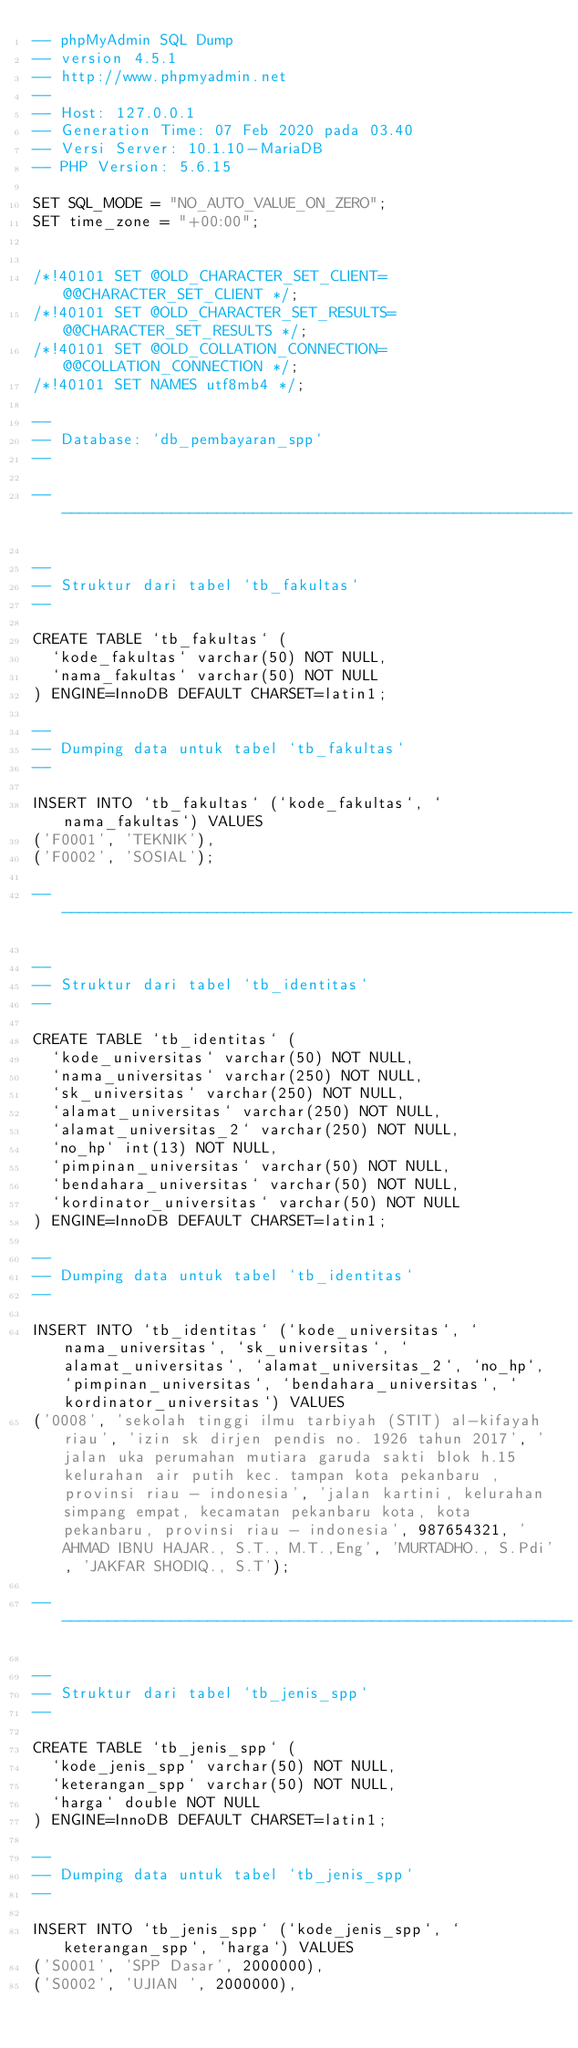<code> <loc_0><loc_0><loc_500><loc_500><_SQL_>-- phpMyAdmin SQL Dump
-- version 4.5.1
-- http://www.phpmyadmin.net
--
-- Host: 127.0.0.1
-- Generation Time: 07 Feb 2020 pada 03.40
-- Versi Server: 10.1.10-MariaDB
-- PHP Version: 5.6.15

SET SQL_MODE = "NO_AUTO_VALUE_ON_ZERO";
SET time_zone = "+00:00";


/*!40101 SET @OLD_CHARACTER_SET_CLIENT=@@CHARACTER_SET_CLIENT */;
/*!40101 SET @OLD_CHARACTER_SET_RESULTS=@@CHARACTER_SET_RESULTS */;
/*!40101 SET @OLD_COLLATION_CONNECTION=@@COLLATION_CONNECTION */;
/*!40101 SET NAMES utf8mb4 */;

--
-- Database: `db_pembayaran_spp`
--

-- --------------------------------------------------------

--
-- Struktur dari tabel `tb_fakultas`
--

CREATE TABLE `tb_fakultas` (
  `kode_fakultas` varchar(50) NOT NULL,
  `nama_fakultas` varchar(50) NOT NULL
) ENGINE=InnoDB DEFAULT CHARSET=latin1;

--
-- Dumping data untuk tabel `tb_fakultas`
--

INSERT INTO `tb_fakultas` (`kode_fakultas`, `nama_fakultas`) VALUES
('F0001', 'TEKNIK'),
('F0002', 'SOSIAL');

-- --------------------------------------------------------

--
-- Struktur dari tabel `tb_identitas`
--

CREATE TABLE `tb_identitas` (
  `kode_universitas` varchar(50) NOT NULL,
  `nama_universitas` varchar(250) NOT NULL,
  `sk_universitas` varchar(250) NOT NULL,
  `alamat_universitas` varchar(250) NOT NULL,
  `alamat_universitas_2` varchar(250) NOT NULL,
  `no_hp` int(13) NOT NULL,
  `pimpinan_universitas` varchar(50) NOT NULL,
  `bendahara_universitas` varchar(50) NOT NULL,
  `kordinator_universitas` varchar(50) NOT NULL
) ENGINE=InnoDB DEFAULT CHARSET=latin1;

--
-- Dumping data untuk tabel `tb_identitas`
--

INSERT INTO `tb_identitas` (`kode_universitas`, `nama_universitas`, `sk_universitas`, `alamat_universitas`, `alamat_universitas_2`, `no_hp`, `pimpinan_universitas`, `bendahara_universitas`, `kordinator_universitas`) VALUES
('0008', 'sekolah tinggi ilmu tarbiyah (STIT) al-kifayah riau', 'izin sk dirjen pendis no. 1926 tahun 2017', 'jalan uka perumahan mutiara garuda sakti blok h.15 kelurahan air putih kec. tampan kota pekanbaru , provinsi riau - indonesia', 'jalan kartini, kelurahan simpang empat, kecamatan pekanbaru kota, kota pekanbaru, provinsi riau - indonesia', 987654321, 'AHMAD IBNU HAJAR., S.T., M.T.,Eng', 'MURTADHO., S.Pdi', 'JAKFAR SHODIQ., S.T');

-- --------------------------------------------------------

--
-- Struktur dari tabel `tb_jenis_spp`
--

CREATE TABLE `tb_jenis_spp` (
  `kode_jenis_spp` varchar(50) NOT NULL,
  `keterangan_spp` varchar(50) NOT NULL,
  `harga` double NOT NULL
) ENGINE=InnoDB DEFAULT CHARSET=latin1;

--
-- Dumping data untuk tabel `tb_jenis_spp`
--

INSERT INTO `tb_jenis_spp` (`kode_jenis_spp`, `keterangan_spp`, `harga`) VALUES
('S0001', 'SPP Dasar', 2000000),
('S0002', 'UJIAN ', 2000000),</code> 